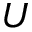<formula> <loc_0><loc_0><loc_500><loc_500>U</formula> 